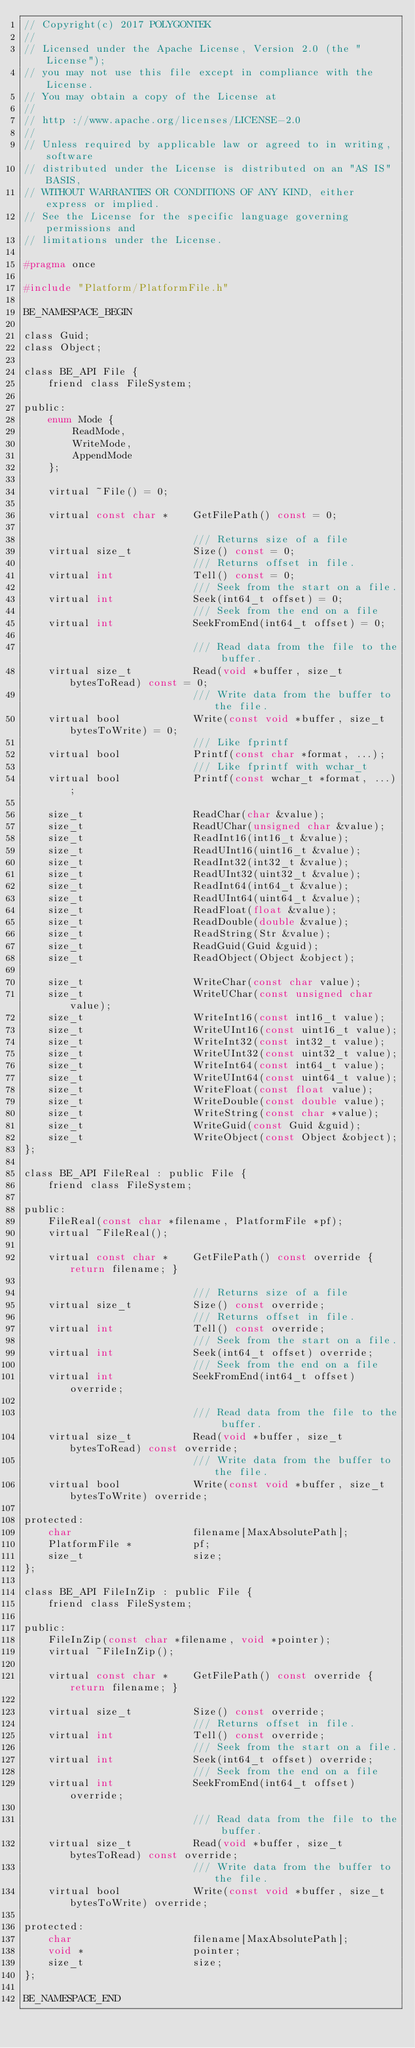Convert code to text. <code><loc_0><loc_0><loc_500><loc_500><_C_>// Copyright(c) 2017 POLYGONTEK
// 
// Licensed under the Apache License, Version 2.0 (the "License");
// you may not use this file except in compliance with the License.
// You may obtain a copy of the License at
// 
// http ://www.apache.org/licenses/LICENSE-2.0
// 
// Unless required by applicable law or agreed to in writing, software
// distributed under the License is distributed on an "AS IS" BASIS,
// WITHOUT WARRANTIES OR CONDITIONS OF ANY KIND, either express or implied.
// See the License for the specific language governing permissions and
// limitations under the License.

#pragma once

#include "Platform/PlatformFile.h"

BE_NAMESPACE_BEGIN

class Guid;
class Object;

class BE_API File {
    friend class FileSystem;

public:
    enum Mode {
        ReadMode,
        WriteMode,
        AppendMode
    };
    
    virtual ~File() = 0;

    virtual const char *    GetFilePath() const = 0;

                            /// Returns size of a file
    virtual size_t          Size() const = 0;
                            /// Returns offset in file.
    virtual int             Tell() const = 0;
                            /// Seek from the start on a file.
    virtual int             Seek(int64_t offset) = 0;
                            /// Seek from the end on a file
    virtual int             SeekFromEnd(int64_t offset) = 0;
    
                            /// Read data from the file to the buffer.
    virtual size_t          Read(void *buffer, size_t bytesToRead) const = 0;
                            /// Write data from the buffer to the file.
    virtual bool            Write(const void *buffer, size_t bytesToWrite) = 0;
                            /// Like fprintf
    virtual bool            Printf(const char *format, ...);
                            /// Like fprintf with wchar_t
    virtual bool            Printf(const wchar_t *format, ...);

    size_t                  ReadChar(char &value);
    size_t                  ReadUChar(unsigned char &value);
    size_t                  ReadInt16(int16_t &value);
    size_t                  ReadUInt16(uint16_t &value);
    size_t                  ReadInt32(int32_t &value);
    size_t                  ReadUInt32(uint32_t &value);
    size_t                  ReadInt64(int64_t &value);
    size_t                  ReadUInt64(uint64_t &value);
    size_t                  ReadFloat(float &value);
    size_t                  ReadDouble(double &value);
    size_t                  ReadString(Str &value);
    size_t                  ReadGuid(Guid &guid);
    size_t                  ReadObject(Object &object);

    size_t                  WriteChar(const char value);
    size_t                  WriteUChar(const unsigned char value);
    size_t                  WriteInt16(const int16_t value);
    size_t                  WriteUInt16(const uint16_t value);
    size_t                  WriteInt32(const int32_t value);
    size_t                  WriteUInt32(const uint32_t value);
    size_t                  WriteInt64(const int64_t value);
    size_t                  WriteUInt64(const uint64_t value);
    size_t                  WriteFloat(const float value);
    size_t                  WriteDouble(const double value);
    size_t                  WriteString(const char *value);
    size_t                  WriteGuid(const Guid &guid);
    size_t                  WriteObject(const Object &object);
};

class BE_API FileReal : public File {
    friend class FileSystem;

public:
    FileReal(const char *filename, PlatformFile *pf);
    virtual ~FileReal();
    
    virtual const char *    GetFilePath() const override { return filename; }
    
                            /// Returns size of a file 
    virtual size_t          Size() const override;
                            /// Returns offset in file.
    virtual int             Tell() const override;
                            /// Seek from the start on a file.
    virtual int             Seek(int64_t offset) override;
                            /// Seek from the end on a file
    virtual int             SeekFromEnd(int64_t offset) override;
    
                            /// Read data from the file to the buffer.
    virtual size_t          Read(void *buffer, size_t bytesToRead) const override;
                            /// Write data from the buffer to the file.
    virtual bool            Write(const void *buffer, size_t bytesToWrite) override;
    
protected:
    char                    filename[MaxAbsolutePath];
    PlatformFile *          pf;
    size_t                  size;
};

class BE_API FileInZip : public File {
    friend class FileSystem;
    
public:
    FileInZip(const char *filename, void *pointer);
    virtual ~FileInZip();
    
    virtual const char *    GetFilePath() const override { return filename; }
    
    virtual size_t          Size() const override;
                            /// Returns offset in file.
    virtual int             Tell() const override;
                            /// Seek from the start on a file.
    virtual int             Seek(int64_t offset) override;
                            /// Seek from the end on a file
    virtual int             SeekFromEnd(int64_t offset) override;
    
                            /// Read data from the file to the buffer.
    virtual size_t          Read(void *buffer, size_t bytesToRead) const override;
                            /// Write data from the buffer to the file.
    virtual bool            Write(const void *buffer, size_t bytesToWrite) override;
    
protected:
    char                    filename[MaxAbsolutePath];
    void *                  pointer;
    size_t                  size;
};

BE_NAMESPACE_END
</code> 